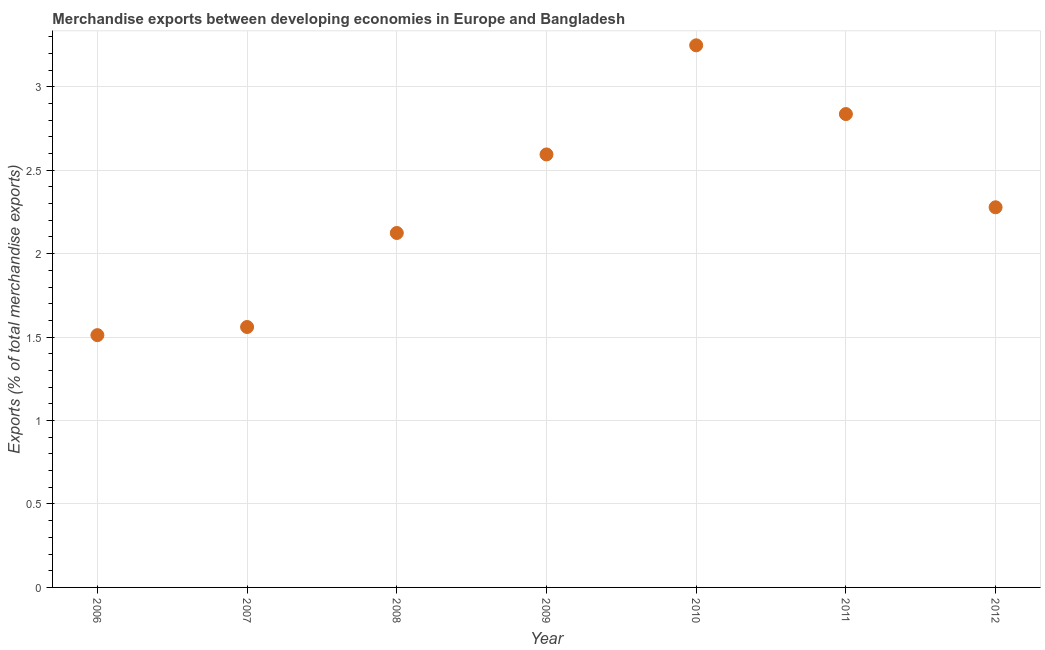What is the merchandise exports in 2006?
Your answer should be compact. 1.51. Across all years, what is the maximum merchandise exports?
Your answer should be very brief. 3.25. Across all years, what is the minimum merchandise exports?
Give a very brief answer. 1.51. In which year was the merchandise exports minimum?
Offer a terse response. 2006. What is the sum of the merchandise exports?
Provide a succinct answer. 16.15. What is the difference between the merchandise exports in 2006 and 2009?
Provide a succinct answer. -1.08. What is the average merchandise exports per year?
Keep it short and to the point. 2.31. What is the median merchandise exports?
Offer a terse response. 2.28. In how many years, is the merchandise exports greater than 0.9 %?
Your answer should be compact. 7. Do a majority of the years between 2009 and 2012 (inclusive) have merchandise exports greater than 2.3 %?
Offer a terse response. Yes. What is the ratio of the merchandise exports in 2006 to that in 2008?
Your response must be concise. 0.71. What is the difference between the highest and the second highest merchandise exports?
Give a very brief answer. 0.41. What is the difference between the highest and the lowest merchandise exports?
Offer a terse response. 1.74. Does the merchandise exports monotonically increase over the years?
Make the answer very short. No. How many dotlines are there?
Your answer should be compact. 1. What is the difference between two consecutive major ticks on the Y-axis?
Keep it short and to the point. 0.5. Does the graph contain grids?
Make the answer very short. Yes. What is the title of the graph?
Keep it short and to the point. Merchandise exports between developing economies in Europe and Bangladesh. What is the label or title of the Y-axis?
Your response must be concise. Exports (% of total merchandise exports). What is the Exports (% of total merchandise exports) in 2006?
Your answer should be very brief. 1.51. What is the Exports (% of total merchandise exports) in 2007?
Give a very brief answer. 1.56. What is the Exports (% of total merchandise exports) in 2008?
Keep it short and to the point. 2.12. What is the Exports (% of total merchandise exports) in 2009?
Offer a terse response. 2.59. What is the Exports (% of total merchandise exports) in 2010?
Your response must be concise. 3.25. What is the Exports (% of total merchandise exports) in 2011?
Provide a short and direct response. 2.84. What is the Exports (% of total merchandise exports) in 2012?
Provide a succinct answer. 2.28. What is the difference between the Exports (% of total merchandise exports) in 2006 and 2007?
Your answer should be very brief. -0.05. What is the difference between the Exports (% of total merchandise exports) in 2006 and 2008?
Your answer should be very brief. -0.61. What is the difference between the Exports (% of total merchandise exports) in 2006 and 2009?
Your answer should be compact. -1.08. What is the difference between the Exports (% of total merchandise exports) in 2006 and 2010?
Make the answer very short. -1.74. What is the difference between the Exports (% of total merchandise exports) in 2006 and 2011?
Your response must be concise. -1.32. What is the difference between the Exports (% of total merchandise exports) in 2006 and 2012?
Give a very brief answer. -0.77. What is the difference between the Exports (% of total merchandise exports) in 2007 and 2008?
Your answer should be very brief. -0.56. What is the difference between the Exports (% of total merchandise exports) in 2007 and 2009?
Give a very brief answer. -1.03. What is the difference between the Exports (% of total merchandise exports) in 2007 and 2010?
Provide a short and direct response. -1.69. What is the difference between the Exports (% of total merchandise exports) in 2007 and 2011?
Make the answer very short. -1.28. What is the difference between the Exports (% of total merchandise exports) in 2007 and 2012?
Ensure brevity in your answer.  -0.72. What is the difference between the Exports (% of total merchandise exports) in 2008 and 2009?
Keep it short and to the point. -0.47. What is the difference between the Exports (% of total merchandise exports) in 2008 and 2010?
Offer a terse response. -1.12. What is the difference between the Exports (% of total merchandise exports) in 2008 and 2011?
Provide a succinct answer. -0.71. What is the difference between the Exports (% of total merchandise exports) in 2008 and 2012?
Your response must be concise. -0.15. What is the difference between the Exports (% of total merchandise exports) in 2009 and 2010?
Provide a succinct answer. -0.65. What is the difference between the Exports (% of total merchandise exports) in 2009 and 2011?
Ensure brevity in your answer.  -0.24. What is the difference between the Exports (% of total merchandise exports) in 2009 and 2012?
Offer a very short reply. 0.32. What is the difference between the Exports (% of total merchandise exports) in 2010 and 2011?
Give a very brief answer. 0.41. What is the difference between the Exports (% of total merchandise exports) in 2010 and 2012?
Your response must be concise. 0.97. What is the difference between the Exports (% of total merchandise exports) in 2011 and 2012?
Offer a very short reply. 0.56. What is the ratio of the Exports (% of total merchandise exports) in 2006 to that in 2008?
Offer a very short reply. 0.71. What is the ratio of the Exports (% of total merchandise exports) in 2006 to that in 2009?
Ensure brevity in your answer.  0.58. What is the ratio of the Exports (% of total merchandise exports) in 2006 to that in 2010?
Offer a very short reply. 0.47. What is the ratio of the Exports (% of total merchandise exports) in 2006 to that in 2011?
Provide a short and direct response. 0.53. What is the ratio of the Exports (% of total merchandise exports) in 2006 to that in 2012?
Give a very brief answer. 0.66. What is the ratio of the Exports (% of total merchandise exports) in 2007 to that in 2008?
Offer a terse response. 0.73. What is the ratio of the Exports (% of total merchandise exports) in 2007 to that in 2009?
Offer a terse response. 0.6. What is the ratio of the Exports (% of total merchandise exports) in 2007 to that in 2010?
Give a very brief answer. 0.48. What is the ratio of the Exports (% of total merchandise exports) in 2007 to that in 2011?
Keep it short and to the point. 0.55. What is the ratio of the Exports (% of total merchandise exports) in 2007 to that in 2012?
Provide a succinct answer. 0.69. What is the ratio of the Exports (% of total merchandise exports) in 2008 to that in 2009?
Give a very brief answer. 0.82. What is the ratio of the Exports (% of total merchandise exports) in 2008 to that in 2010?
Make the answer very short. 0.65. What is the ratio of the Exports (% of total merchandise exports) in 2008 to that in 2011?
Provide a short and direct response. 0.75. What is the ratio of the Exports (% of total merchandise exports) in 2008 to that in 2012?
Keep it short and to the point. 0.93. What is the ratio of the Exports (% of total merchandise exports) in 2009 to that in 2010?
Your response must be concise. 0.8. What is the ratio of the Exports (% of total merchandise exports) in 2009 to that in 2011?
Give a very brief answer. 0.92. What is the ratio of the Exports (% of total merchandise exports) in 2009 to that in 2012?
Keep it short and to the point. 1.14. What is the ratio of the Exports (% of total merchandise exports) in 2010 to that in 2011?
Make the answer very short. 1.15. What is the ratio of the Exports (% of total merchandise exports) in 2010 to that in 2012?
Give a very brief answer. 1.43. What is the ratio of the Exports (% of total merchandise exports) in 2011 to that in 2012?
Offer a terse response. 1.25. 